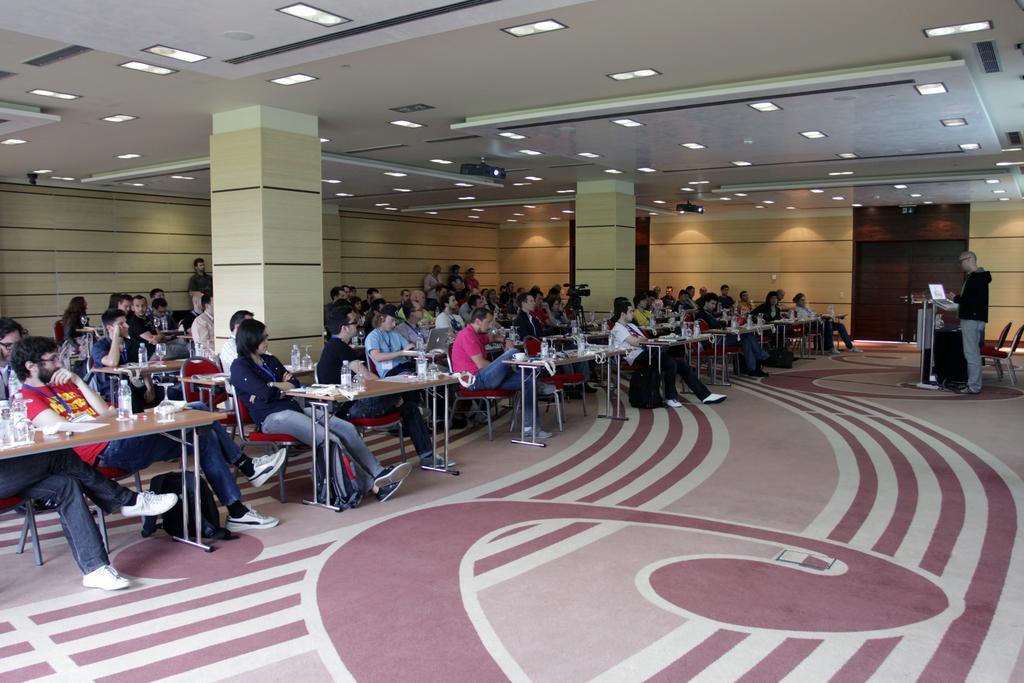Could you give a brief overview of what you see in this image? In this picture many people are siting on tables on which water bottles and notebooks are on top of it. There are many LED lights attached to the roof. There is also a guy standing to the right side of the image explaining them with the help of a laptop. 